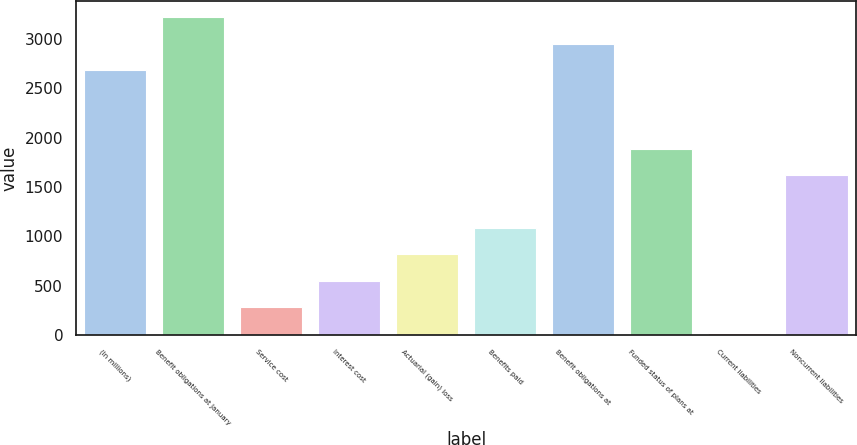Convert chart. <chart><loc_0><loc_0><loc_500><loc_500><bar_chart><fcel>(In millions)<fcel>Benefit obligations at January<fcel>Service cost<fcel>Interest cost<fcel>Actuarial (gain) loss<fcel>Benefits paid<fcel>Benefit obligations at<fcel>Funded status of plans at<fcel>Current liabilities<fcel>Noncurrent liabilities<nl><fcel>2685<fcel>3218.4<fcel>284.7<fcel>551.4<fcel>818.1<fcel>1084.8<fcel>2951.7<fcel>1884.9<fcel>18<fcel>1618.2<nl></chart> 